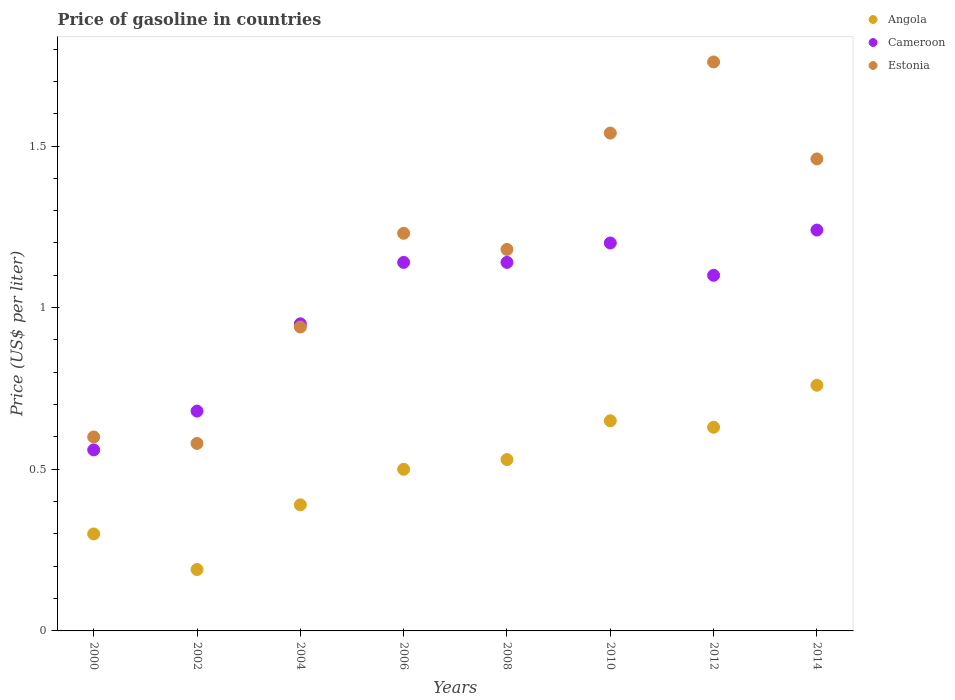How many different coloured dotlines are there?
Your response must be concise. 3. What is the price of gasoline in Estonia in 2000?
Keep it short and to the point. 0.6. Across all years, what is the maximum price of gasoline in Angola?
Your response must be concise. 0.76. Across all years, what is the minimum price of gasoline in Cameroon?
Keep it short and to the point. 0.56. In which year was the price of gasoline in Estonia maximum?
Keep it short and to the point. 2012. What is the total price of gasoline in Cameroon in the graph?
Make the answer very short. 8.01. What is the difference between the price of gasoline in Cameroon in 2004 and that in 2010?
Give a very brief answer. -0.25. What is the difference between the price of gasoline in Angola in 2010 and the price of gasoline in Estonia in 2008?
Provide a succinct answer. -0.53. What is the average price of gasoline in Angola per year?
Your answer should be very brief. 0.49. In how many years, is the price of gasoline in Estonia greater than 1.2 US$?
Your answer should be very brief. 4. What is the ratio of the price of gasoline in Cameroon in 2002 to that in 2010?
Provide a succinct answer. 0.57. What is the difference between the highest and the second highest price of gasoline in Angola?
Provide a succinct answer. 0.11. What is the difference between the highest and the lowest price of gasoline in Angola?
Ensure brevity in your answer.  0.57. In how many years, is the price of gasoline in Cameroon greater than the average price of gasoline in Cameroon taken over all years?
Make the answer very short. 5. Is the sum of the price of gasoline in Estonia in 2000 and 2014 greater than the maximum price of gasoline in Angola across all years?
Your answer should be very brief. Yes. Is it the case that in every year, the sum of the price of gasoline in Angola and price of gasoline in Cameroon  is greater than the price of gasoline in Estonia?
Offer a very short reply. No. Does the price of gasoline in Angola monotonically increase over the years?
Provide a succinct answer. No. Is the price of gasoline in Cameroon strictly greater than the price of gasoline in Angola over the years?
Provide a succinct answer. Yes. How many years are there in the graph?
Offer a terse response. 8. What is the difference between two consecutive major ticks on the Y-axis?
Make the answer very short. 0.5. Does the graph contain any zero values?
Provide a short and direct response. No. Does the graph contain grids?
Make the answer very short. No. Where does the legend appear in the graph?
Offer a terse response. Top right. What is the title of the graph?
Keep it short and to the point. Price of gasoline in countries. Does "Netherlands" appear as one of the legend labels in the graph?
Offer a very short reply. No. What is the label or title of the X-axis?
Offer a very short reply. Years. What is the label or title of the Y-axis?
Make the answer very short. Price (US$ per liter). What is the Price (US$ per liter) in Cameroon in 2000?
Your response must be concise. 0.56. What is the Price (US$ per liter) in Angola in 2002?
Give a very brief answer. 0.19. What is the Price (US$ per liter) of Cameroon in 2002?
Offer a terse response. 0.68. What is the Price (US$ per liter) in Estonia in 2002?
Your response must be concise. 0.58. What is the Price (US$ per liter) in Angola in 2004?
Your answer should be very brief. 0.39. What is the Price (US$ per liter) in Angola in 2006?
Provide a succinct answer. 0.5. What is the Price (US$ per liter) in Cameroon in 2006?
Your response must be concise. 1.14. What is the Price (US$ per liter) of Estonia in 2006?
Your answer should be very brief. 1.23. What is the Price (US$ per liter) of Angola in 2008?
Your response must be concise. 0.53. What is the Price (US$ per liter) in Cameroon in 2008?
Your response must be concise. 1.14. What is the Price (US$ per liter) in Estonia in 2008?
Provide a short and direct response. 1.18. What is the Price (US$ per liter) in Angola in 2010?
Ensure brevity in your answer.  0.65. What is the Price (US$ per liter) in Cameroon in 2010?
Keep it short and to the point. 1.2. What is the Price (US$ per liter) of Estonia in 2010?
Provide a succinct answer. 1.54. What is the Price (US$ per liter) of Angola in 2012?
Offer a very short reply. 0.63. What is the Price (US$ per liter) of Estonia in 2012?
Your response must be concise. 1.76. What is the Price (US$ per liter) of Angola in 2014?
Provide a succinct answer. 0.76. What is the Price (US$ per liter) in Cameroon in 2014?
Ensure brevity in your answer.  1.24. What is the Price (US$ per liter) of Estonia in 2014?
Provide a succinct answer. 1.46. Across all years, what is the maximum Price (US$ per liter) of Angola?
Give a very brief answer. 0.76. Across all years, what is the maximum Price (US$ per liter) in Cameroon?
Your answer should be very brief. 1.24. Across all years, what is the maximum Price (US$ per liter) in Estonia?
Offer a terse response. 1.76. Across all years, what is the minimum Price (US$ per liter) in Angola?
Keep it short and to the point. 0.19. Across all years, what is the minimum Price (US$ per liter) of Cameroon?
Provide a short and direct response. 0.56. Across all years, what is the minimum Price (US$ per liter) of Estonia?
Your response must be concise. 0.58. What is the total Price (US$ per liter) of Angola in the graph?
Offer a terse response. 3.95. What is the total Price (US$ per liter) of Cameroon in the graph?
Make the answer very short. 8.01. What is the total Price (US$ per liter) of Estonia in the graph?
Provide a succinct answer. 9.29. What is the difference between the Price (US$ per liter) in Angola in 2000 and that in 2002?
Offer a terse response. 0.11. What is the difference between the Price (US$ per liter) in Cameroon in 2000 and that in 2002?
Give a very brief answer. -0.12. What is the difference between the Price (US$ per liter) in Estonia in 2000 and that in 2002?
Your answer should be compact. 0.02. What is the difference between the Price (US$ per liter) of Angola in 2000 and that in 2004?
Give a very brief answer. -0.09. What is the difference between the Price (US$ per liter) in Cameroon in 2000 and that in 2004?
Offer a terse response. -0.39. What is the difference between the Price (US$ per liter) in Estonia in 2000 and that in 2004?
Ensure brevity in your answer.  -0.34. What is the difference between the Price (US$ per liter) in Angola in 2000 and that in 2006?
Keep it short and to the point. -0.2. What is the difference between the Price (US$ per liter) in Cameroon in 2000 and that in 2006?
Offer a terse response. -0.58. What is the difference between the Price (US$ per liter) in Estonia in 2000 and that in 2006?
Offer a terse response. -0.63. What is the difference between the Price (US$ per liter) of Angola in 2000 and that in 2008?
Ensure brevity in your answer.  -0.23. What is the difference between the Price (US$ per liter) of Cameroon in 2000 and that in 2008?
Ensure brevity in your answer.  -0.58. What is the difference between the Price (US$ per liter) in Estonia in 2000 and that in 2008?
Offer a terse response. -0.58. What is the difference between the Price (US$ per liter) in Angola in 2000 and that in 2010?
Keep it short and to the point. -0.35. What is the difference between the Price (US$ per liter) in Cameroon in 2000 and that in 2010?
Give a very brief answer. -0.64. What is the difference between the Price (US$ per liter) of Estonia in 2000 and that in 2010?
Give a very brief answer. -0.94. What is the difference between the Price (US$ per liter) of Angola in 2000 and that in 2012?
Your answer should be compact. -0.33. What is the difference between the Price (US$ per liter) of Cameroon in 2000 and that in 2012?
Offer a terse response. -0.54. What is the difference between the Price (US$ per liter) of Estonia in 2000 and that in 2012?
Make the answer very short. -1.16. What is the difference between the Price (US$ per liter) of Angola in 2000 and that in 2014?
Your response must be concise. -0.46. What is the difference between the Price (US$ per liter) of Cameroon in 2000 and that in 2014?
Your response must be concise. -0.68. What is the difference between the Price (US$ per liter) in Estonia in 2000 and that in 2014?
Your response must be concise. -0.86. What is the difference between the Price (US$ per liter) of Angola in 2002 and that in 2004?
Offer a terse response. -0.2. What is the difference between the Price (US$ per liter) of Cameroon in 2002 and that in 2004?
Provide a succinct answer. -0.27. What is the difference between the Price (US$ per liter) in Estonia in 2002 and that in 2004?
Keep it short and to the point. -0.36. What is the difference between the Price (US$ per liter) of Angola in 2002 and that in 2006?
Your answer should be very brief. -0.31. What is the difference between the Price (US$ per liter) of Cameroon in 2002 and that in 2006?
Your answer should be very brief. -0.46. What is the difference between the Price (US$ per liter) in Estonia in 2002 and that in 2006?
Keep it short and to the point. -0.65. What is the difference between the Price (US$ per liter) of Angola in 2002 and that in 2008?
Your answer should be very brief. -0.34. What is the difference between the Price (US$ per liter) in Cameroon in 2002 and that in 2008?
Ensure brevity in your answer.  -0.46. What is the difference between the Price (US$ per liter) in Estonia in 2002 and that in 2008?
Offer a terse response. -0.6. What is the difference between the Price (US$ per liter) in Angola in 2002 and that in 2010?
Make the answer very short. -0.46. What is the difference between the Price (US$ per liter) in Cameroon in 2002 and that in 2010?
Make the answer very short. -0.52. What is the difference between the Price (US$ per liter) in Estonia in 2002 and that in 2010?
Your answer should be very brief. -0.96. What is the difference between the Price (US$ per liter) of Angola in 2002 and that in 2012?
Provide a short and direct response. -0.44. What is the difference between the Price (US$ per liter) in Cameroon in 2002 and that in 2012?
Your response must be concise. -0.42. What is the difference between the Price (US$ per liter) in Estonia in 2002 and that in 2012?
Your answer should be compact. -1.18. What is the difference between the Price (US$ per liter) in Angola in 2002 and that in 2014?
Offer a very short reply. -0.57. What is the difference between the Price (US$ per liter) in Cameroon in 2002 and that in 2014?
Ensure brevity in your answer.  -0.56. What is the difference between the Price (US$ per liter) of Estonia in 2002 and that in 2014?
Make the answer very short. -0.88. What is the difference between the Price (US$ per liter) of Angola in 2004 and that in 2006?
Make the answer very short. -0.11. What is the difference between the Price (US$ per liter) of Cameroon in 2004 and that in 2006?
Offer a very short reply. -0.19. What is the difference between the Price (US$ per liter) of Estonia in 2004 and that in 2006?
Offer a very short reply. -0.29. What is the difference between the Price (US$ per liter) of Angola in 2004 and that in 2008?
Make the answer very short. -0.14. What is the difference between the Price (US$ per liter) of Cameroon in 2004 and that in 2008?
Provide a short and direct response. -0.19. What is the difference between the Price (US$ per liter) in Estonia in 2004 and that in 2008?
Keep it short and to the point. -0.24. What is the difference between the Price (US$ per liter) of Angola in 2004 and that in 2010?
Provide a succinct answer. -0.26. What is the difference between the Price (US$ per liter) of Cameroon in 2004 and that in 2010?
Offer a very short reply. -0.25. What is the difference between the Price (US$ per liter) in Angola in 2004 and that in 2012?
Provide a succinct answer. -0.24. What is the difference between the Price (US$ per liter) of Cameroon in 2004 and that in 2012?
Keep it short and to the point. -0.15. What is the difference between the Price (US$ per liter) of Estonia in 2004 and that in 2012?
Give a very brief answer. -0.82. What is the difference between the Price (US$ per liter) in Angola in 2004 and that in 2014?
Give a very brief answer. -0.37. What is the difference between the Price (US$ per liter) of Cameroon in 2004 and that in 2014?
Provide a succinct answer. -0.29. What is the difference between the Price (US$ per liter) of Estonia in 2004 and that in 2014?
Your response must be concise. -0.52. What is the difference between the Price (US$ per liter) of Angola in 2006 and that in 2008?
Offer a terse response. -0.03. What is the difference between the Price (US$ per liter) of Cameroon in 2006 and that in 2008?
Offer a terse response. 0. What is the difference between the Price (US$ per liter) of Angola in 2006 and that in 2010?
Provide a succinct answer. -0.15. What is the difference between the Price (US$ per liter) of Cameroon in 2006 and that in 2010?
Offer a very short reply. -0.06. What is the difference between the Price (US$ per liter) in Estonia in 2006 and that in 2010?
Offer a very short reply. -0.31. What is the difference between the Price (US$ per liter) of Angola in 2006 and that in 2012?
Offer a terse response. -0.13. What is the difference between the Price (US$ per liter) of Cameroon in 2006 and that in 2012?
Give a very brief answer. 0.04. What is the difference between the Price (US$ per liter) of Estonia in 2006 and that in 2012?
Provide a short and direct response. -0.53. What is the difference between the Price (US$ per liter) of Angola in 2006 and that in 2014?
Ensure brevity in your answer.  -0.26. What is the difference between the Price (US$ per liter) in Cameroon in 2006 and that in 2014?
Ensure brevity in your answer.  -0.1. What is the difference between the Price (US$ per liter) in Estonia in 2006 and that in 2014?
Offer a terse response. -0.23. What is the difference between the Price (US$ per liter) in Angola in 2008 and that in 2010?
Offer a very short reply. -0.12. What is the difference between the Price (US$ per liter) of Cameroon in 2008 and that in 2010?
Offer a very short reply. -0.06. What is the difference between the Price (US$ per liter) in Estonia in 2008 and that in 2010?
Ensure brevity in your answer.  -0.36. What is the difference between the Price (US$ per liter) of Cameroon in 2008 and that in 2012?
Your response must be concise. 0.04. What is the difference between the Price (US$ per liter) of Estonia in 2008 and that in 2012?
Your answer should be very brief. -0.58. What is the difference between the Price (US$ per liter) in Angola in 2008 and that in 2014?
Ensure brevity in your answer.  -0.23. What is the difference between the Price (US$ per liter) in Cameroon in 2008 and that in 2014?
Your answer should be very brief. -0.1. What is the difference between the Price (US$ per liter) of Estonia in 2008 and that in 2014?
Offer a terse response. -0.28. What is the difference between the Price (US$ per liter) of Angola in 2010 and that in 2012?
Give a very brief answer. 0.02. What is the difference between the Price (US$ per liter) in Estonia in 2010 and that in 2012?
Your response must be concise. -0.22. What is the difference between the Price (US$ per liter) of Angola in 2010 and that in 2014?
Provide a short and direct response. -0.11. What is the difference between the Price (US$ per liter) of Cameroon in 2010 and that in 2014?
Offer a terse response. -0.04. What is the difference between the Price (US$ per liter) in Angola in 2012 and that in 2014?
Give a very brief answer. -0.13. What is the difference between the Price (US$ per liter) in Cameroon in 2012 and that in 2014?
Your response must be concise. -0.14. What is the difference between the Price (US$ per liter) in Angola in 2000 and the Price (US$ per liter) in Cameroon in 2002?
Give a very brief answer. -0.38. What is the difference between the Price (US$ per liter) in Angola in 2000 and the Price (US$ per liter) in Estonia in 2002?
Offer a very short reply. -0.28. What is the difference between the Price (US$ per liter) of Cameroon in 2000 and the Price (US$ per liter) of Estonia in 2002?
Give a very brief answer. -0.02. What is the difference between the Price (US$ per liter) of Angola in 2000 and the Price (US$ per liter) of Cameroon in 2004?
Provide a short and direct response. -0.65. What is the difference between the Price (US$ per liter) in Angola in 2000 and the Price (US$ per liter) in Estonia in 2004?
Keep it short and to the point. -0.64. What is the difference between the Price (US$ per liter) of Cameroon in 2000 and the Price (US$ per liter) of Estonia in 2004?
Offer a very short reply. -0.38. What is the difference between the Price (US$ per liter) of Angola in 2000 and the Price (US$ per liter) of Cameroon in 2006?
Make the answer very short. -0.84. What is the difference between the Price (US$ per liter) in Angola in 2000 and the Price (US$ per liter) in Estonia in 2006?
Offer a very short reply. -0.93. What is the difference between the Price (US$ per liter) of Cameroon in 2000 and the Price (US$ per liter) of Estonia in 2006?
Your answer should be compact. -0.67. What is the difference between the Price (US$ per liter) in Angola in 2000 and the Price (US$ per liter) in Cameroon in 2008?
Offer a terse response. -0.84. What is the difference between the Price (US$ per liter) of Angola in 2000 and the Price (US$ per liter) of Estonia in 2008?
Make the answer very short. -0.88. What is the difference between the Price (US$ per liter) in Cameroon in 2000 and the Price (US$ per liter) in Estonia in 2008?
Offer a very short reply. -0.62. What is the difference between the Price (US$ per liter) in Angola in 2000 and the Price (US$ per liter) in Estonia in 2010?
Offer a terse response. -1.24. What is the difference between the Price (US$ per liter) of Cameroon in 2000 and the Price (US$ per liter) of Estonia in 2010?
Your answer should be very brief. -0.98. What is the difference between the Price (US$ per liter) in Angola in 2000 and the Price (US$ per liter) in Cameroon in 2012?
Give a very brief answer. -0.8. What is the difference between the Price (US$ per liter) in Angola in 2000 and the Price (US$ per liter) in Estonia in 2012?
Keep it short and to the point. -1.46. What is the difference between the Price (US$ per liter) in Cameroon in 2000 and the Price (US$ per liter) in Estonia in 2012?
Make the answer very short. -1.2. What is the difference between the Price (US$ per liter) of Angola in 2000 and the Price (US$ per liter) of Cameroon in 2014?
Ensure brevity in your answer.  -0.94. What is the difference between the Price (US$ per liter) of Angola in 2000 and the Price (US$ per liter) of Estonia in 2014?
Make the answer very short. -1.16. What is the difference between the Price (US$ per liter) in Angola in 2002 and the Price (US$ per liter) in Cameroon in 2004?
Make the answer very short. -0.76. What is the difference between the Price (US$ per liter) in Angola in 2002 and the Price (US$ per liter) in Estonia in 2004?
Keep it short and to the point. -0.75. What is the difference between the Price (US$ per liter) in Cameroon in 2002 and the Price (US$ per liter) in Estonia in 2004?
Your answer should be compact. -0.26. What is the difference between the Price (US$ per liter) of Angola in 2002 and the Price (US$ per liter) of Cameroon in 2006?
Provide a short and direct response. -0.95. What is the difference between the Price (US$ per liter) of Angola in 2002 and the Price (US$ per liter) of Estonia in 2006?
Provide a short and direct response. -1.04. What is the difference between the Price (US$ per liter) in Cameroon in 2002 and the Price (US$ per liter) in Estonia in 2006?
Offer a very short reply. -0.55. What is the difference between the Price (US$ per liter) in Angola in 2002 and the Price (US$ per liter) in Cameroon in 2008?
Your response must be concise. -0.95. What is the difference between the Price (US$ per liter) of Angola in 2002 and the Price (US$ per liter) of Estonia in 2008?
Your answer should be compact. -0.99. What is the difference between the Price (US$ per liter) of Cameroon in 2002 and the Price (US$ per liter) of Estonia in 2008?
Offer a terse response. -0.5. What is the difference between the Price (US$ per liter) in Angola in 2002 and the Price (US$ per liter) in Cameroon in 2010?
Offer a terse response. -1.01. What is the difference between the Price (US$ per liter) in Angola in 2002 and the Price (US$ per liter) in Estonia in 2010?
Offer a terse response. -1.35. What is the difference between the Price (US$ per liter) in Cameroon in 2002 and the Price (US$ per liter) in Estonia in 2010?
Your answer should be compact. -0.86. What is the difference between the Price (US$ per liter) in Angola in 2002 and the Price (US$ per liter) in Cameroon in 2012?
Keep it short and to the point. -0.91. What is the difference between the Price (US$ per liter) in Angola in 2002 and the Price (US$ per liter) in Estonia in 2012?
Your response must be concise. -1.57. What is the difference between the Price (US$ per liter) of Cameroon in 2002 and the Price (US$ per liter) of Estonia in 2012?
Give a very brief answer. -1.08. What is the difference between the Price (US$ per liter) of Angola in 2002 and the Price (US$ per liter) of Cameroon in 2014?
Offer a very short reply. -1.05. What is the difference between the Price (US$ per liter) in Angola in 2002 and the Price (US$ per liter) in Estonia in 2014?
Provide a succinct answer. -1.27. What is the difference between the Price (US$ per liter) in Cameroon in 2002 and the Price (US$ per liter) in Estonia in 2014?
Ensure brevity in your answer.  -0.78. What is the difference between the Price (US$ per liter) in Angola in 2004 and the Price (US$ per liter) in Cameroon in 2006?
Your response must be concise. -0.75. What is the difference between the Price (US$ per liter) of Angola in 2004 and the Price (US$ per liter) of Estonia in 2006?
Give a very brief answer. -0.84. What is the difference between the Price (US$ per liter) in Cameroon in 2004 and the Price (US$ per liter) in Estonia in 2006?
Make the answer very short. -0.28. What is the difference between the Price (US$ per liter) in Angola in 2004 and the Price (US$ per liter) in Cameroon in 2008?
Offer a very short reply. -0.75. What is the difference between the Price (US$ per liter) of Angola in 2004 and the Price (US$ per liter) of Estonia in 2008?
Provide a short and direct response. -0.79. What is the difference between the Price (US$ per liter) in Cameroon in 2004 and the Price (US$ per liter) in Estonia in 2008?
Ensure brevity in your answer.  -0.23. What is the difference between the Price (US$ per liter) in Angola in 2004 and the Price (US$ per liter) in Cameroon in 2010?
Ensure brevity in your answer.  -0.81. What is the difference between the Price (US$ per liter) in Angola in 2004 and the Price (US$ per liter) in Estonia in 2010?
Give a very brief answer. -1.15. What is the difference between the Price (US$ per liter) in Cameroon in 2004 and the Price (US$ per liter) in Estonia in 2010?
Your answer should be compact. -0.59. What is the difference between the Price (US$ per liter) of Angola in 2004 and the Price (US$ per liter) of Cameroon in 2012?
Your response must be concise. -0.71. What is the difference between the Price (US$ per liter) in Angola in 2004 and the Price (US$ per liter) in Estonia in 2012?
Offer a very short reply. -1.37. What is the difference between the Price (US$ per liter) of Cameroon in 2004 and the Price (US$ per liter) of Estonia in 2012?
Your response must be concise. -0.81. What is the difference between the Price (US$ per liter) in Angola in 2004 and the Price (US$ per liter) in Cameroon in 2014?
Your answer should be very brief. -0.85. What is the difference between the Price (US$ per liter) of Angola in 2004 and the Price (US$ per liter) of Estonia in 2014?
Your answer should be very brief. -1.07. What is the difference between the Price (US$ per liter) in Cameroon in 2004 and the Price (US$ per liter) in Estonia in 2014?
Your response must be concise. -0.51. What is the difference between the Price (US$ per liter) of Angola in 2006 and the Price (US$ per liter) of Cameroon in 2008?
Offer a terse response. -0.64. What is the difference between the Price (US$ per liter) of Angola in 2006 and the Price (US$ per liter) of Estonia in 2008?
Provide a short and direct response. -0.68. What is the difference between the Price (US$ per liter) of Cameroon in 2006 and the Price (US$ per liter) of Estonia in 2008?
Your answer should be very brief. -0.04. What is the difference between the Price (US$ per liter) of Angola in 2006 and the Price (US$ per liter) of Estonia in 2010?
Keep it short and to the point. -1.04. What is the difference between the Price (US$ per liter) of Angola in 2006 and the Price (US$ per liter) of Estonia in 2012?
Offer a very short reply. -1.26. What is the difference between the Price (US$ per liter) in Cameroon in 2006 and the Price (US$ per liter) in Estonia in 2012?
Provide a short and direct response. -0.62. What is the difference between the Price (US$ per liter) of Angola in 2006 and the Price (US$ per liter) of Cameroon in 2014?
Your answer should be very brief. -0.74. What is the difference between the Price (US$ per liter) of Angola in 2006 and the Price (US$ per liter) of Estonia in 2014?
Provide a short and direct response. -0.96. What is the difference between the Price (US$ per liter) in Cameroon in 2006 and the Price (US$ per liter) in Estonia in 2014?
Make the answer very short. -0.32. What is the difference between the Price (US$ per liter) in Angola in 2008 and the Price (US$ per liter) in Cameroon in 2010?
Your answer should be very brief. -0.67. What is the difference between the Price (US$ per liter) in Angola in 2008 and the Price (US$ per liter) in Estonia in 2010?
Ensure brevity in your answer.  -1.01. What is the difference between the Price (US$ per liter) of Angola in 2008 and the Price (US$ per liter) of Cameroon in 2012?
Your answer should be compact. -0.57. What is the difference between the Price (US$ per liter) of Angola in 2008 and the Price (US$ per liter) of Estonia in 2012?
Offer a very short reply. -1.23. What is the difference between the Price (US$ per liter) of Cameroon in 2008 and the Price (US$ per liter) of Estonia in 2012?
Provide a succinct answer. -0.62. What is the difference between the Price (US$ per liter) of Angola in 2008 and the Price (US$ per liter) of Cameroon in 2014?
Provide a succinct answer. -0.71. What is the difference between the Price (US$ per liter) of Angola in 2008 and the Price (US$ per liter) of Estonia in 2014?
Give a very brief answer. -0.93. What is the difference between the Price (US$ per liter) in Cameroon in 2008 and the Price (US$ per liter) in Estonia in 2014?
Make the answer very short. -0.32. What is the difference between the Price (US$ per liter) of Angola in 2010 and the Price (US$ per liter) of Cameroon in 2012?
Keep it short and to the point. -0.45. What is the difference between the Price (US$ per liter) in Angola in 2010 and the Price (US$ per liter) in Estonia in 2012?
Provide a succinct answer. -1.11. What is the difference between the Price (US$ per liter) of Cameroon in 2010 and the Price (US$ per liter) of Estonia in 2012?
Give a very brief answer. -0.56. What is the difference between the Price (US$ per liter) of Angola in 2010 and the Price (US$ per liter) of Cameroon in 2014?
Your answer should be compact. -0.59. What is the difference between the Price (US$ per liter) in Angola in 2010 and the Price (US$ per liter) in Estonia in 2014?
Your response must be concise. -0.81. What is the difference between the Price (US$ per liter) in Cameroon in 2010 and the Price (US$ per liter) in Estonia in 2014?
Your response must be concise. -0.26. What is the difference between the Price (US$ per liter) in Angola in 2012 and the Price (US$ per liter) in Cameroon in 2014?
Your response must be concise. -0.61. What is the difference between the Price (US$ per liter) in Angola in 2012 and the Price (US$ per liter) in Estonia in 2014?
Your response must be concise. -0.83. What is the difference between the Price (US$ per liter) in Cameroon in 2012 and the Price (US$ per liter) in Estonia in 2014?
Provide a succinct answer. -0.36. What is the average Price (US$ per liter) of Angola per year?
Offer a very short reply. 0.49. What is the average Price (US$ per liter) in Estonia per year?
Provide a short and direct response. 1.16. In the year 2000, what is the difference between the Price (US$ per liter) of Angola and Price (US$ per liter) of Cameroon?
Ensure brevity in your answer.  -0.26. In the year 2000, what is the difference between the Price (US$ per liter) in Cameroon and Price (US$ per liter) in Estonia?
Make the answer very short. -0.04. In the year 2002, what is the difference between the Price (US$ per liter) in Angola and Price (US$ per liter) in Cameroon?
Offer a terse response. -0.49. In the year 2002, what is the difference between the Price (US$ per liter) of Angola and Price (US$ per liter) of Estonia?
Keep it short and to the point. -0.39. In the year 2002, what is the difference between the Price (US$ per liter) in Cameroon and Price (US$ per liter) in Estonia?
Provide a short and direct response. 0.1. In the year 2004, what is the difference between the Price (US$ per liter) in Angola and Price (US$ per liter) in Cameroon?
Your answer should be compact. -0.56. In the year 2004, what is the difference between the Price (US$ per liter) in Angola and Price (US$ per liter) in Estonia?
Provide a succinct answer. -0.55. In the year 2006, what is the difference between the Price (US$ per liter) in Angola and Price (US$ per liter) in Cameroon?
Offer a terse response. -0.64. In the year 2006, what is the difference between the Price (US$ per liter) in Angola and Price (US$ per liter) in Estonia?
Give a very brief answer. -0.73. In the year 2006, what is the difference between the Price (US$ per liter) of Cameroon and Price (US$ per liter) of Estonia?
Keep it short and to the point. -0.09. In the year 2008, what is the difference between the Price (US$ per liter) of Angola and Price (US$ per liter) of Cameroon?
Your answer should be very brief. -0.61. In the year 2008, what is the difference between the Price (US$ per liter) in Angola and Price (US$ per liter) in Estonia?
Your response must be concise. -0.65. In the year 2008, what is the difference between the Price (US$ per liter) in Cameroon and Price (US$ per liter) in Estonia?
Make the answer very short. -0.04. In the year 2010, what is the difference between the Price (US$ per liter) in Angola and Price (US$ per liter) in Cameroon?
Your answer should be very brief. -0.55. In the year 2010, what is the difference between the Price (US$ per liter) of Angola and Price (US$ per liter) of Estonia?
Offer a very short reply. -0.89. In the year 2010, what is the difference between the Price (US$ per liter) of Cameroon and Price (US$ per liter) of Estonia?
Offer a terse response. -0.34. In the year 2012, what is the difference between the Price (US$ per liter) of Angola and Price (US$ per liter) of Cameroon?
Offer a terse response. -0.47. In the year 2012, what is the difference between the Price (US$ per liter) in Angola and Price (US$ per liter) in Estonia?
Provide a short and direct response. -1.13. In the year 2012, what is the difference between the Price (US$ per liter) in Cameroon and Price (US$ per liter) in Estonia?
Give a very brief answer. -0.66. In the year 2014, what is the difference between the Price (US$ per liter) of Angola and Price (US$ per liter) of Cameroon?
Ensure brevity in your answer.  -0.48. In the year 2014, what is the difference between the Price (US$ per liter) in Cameroon and Price (US$ per liter) in Estonia?
Provide a short and direct response. -0.22. What is the ratio of the Price (US$ per liter) of Angola in 2000 to that in 2002?
Offer a very short reply. 1.58. What is the ratio of the Price (US$ per liter) in Cameroon in 2000 to that in 2002?
Provide a succinct answer. 0.82. What is the ratio of the Price (US$ per liter) of Estonia in 2000 to that in 2002?
Your answer should be very brief. 1.03. What is the ratio of the Price (US$ per liter) of Angola in 2000 to that in 2004?
Ensure brevity in your answer.  0.77. What is the ratio of the Price (US$ per liter) in Cameroon in 2000 to that in 2004?
Give a very brief answer. 0.59. What is the ratio of the Price (US$ per liter) of Estonia in 2000 to that in 2004?
Give a very brief answer. 0.64. What is the ratio of the Price (US$ per liter) of Angola in 2000 to that in 2006?
Provide a short and direct response. 0.6. What is the ratio of the Price (US$ per liter) of Cameroon in 2000 to that in 2006?
Ensure brevity in your answer.  0.49. What is the ratio of the Price (US$ per liter) of Estonia in 2000 to that in 2006?
Your answer should be compact. 0.49. What is the ratio of the Price (US$ per liter) of Angola in 2000 to that in 2008?
Your response must be concise. 0.57. What is the ratio of the Price (US$ per liter) of Cameroon in 2000 to that in 2008?
Ensure brevity in your answer.  0.49. What is the ratio of the Price (US$ per liter) of Estonia in 2000 to that in 2008?
Keep it short and to the point. 0.51. What is the ratio of the Price (US$ per liter) of Angola in 2000 to that in 2010?
Keep it short and to the point. 0.46. What is the ratio of the Price (US$ per liter) in Cameroon in 2000 to that in 2010?
Provide a short and direct response. 0.47. What is the ratio of the Price (US$ per liter) in Estonia in 2000 to that in 2010?
Ensure brevity in your answer.  0.39. What is the ratio of the Price (US$ per liter) of Angola in 2000 to that in 2012?
Your response must be concise. 0.48. What is the ratio of the Price (US$ per liter) of Cameroon in 2000 to that in 2012?
Provide a short and direct response. 0.51. What is the ratio of the Price (US$ per liter) in Estonia in 2000 to that in 2012?
Give a very brief answer. 0.34. What is the ratio of the Price (US$ per liter) of Angola in 2000 to that in 2014?
Your answer should be very brief. 0.39. What is the ratio of the Price (US$ per liter) of Cameroon in 2000 to that in 2014?
Give a very brief answer. 0.45. What is the ratio of the Price (US$ per liter) of Estonia in 2000 to that in 2014?
Give a very brief answer. 0.41. What is the ratio of the Price (US$ per liter) of Angola in 2002 to that in 2004?
Offer a terse response. 0.49. What is the ratio of the Price (US$ per liter) of Cameroon in 2002 to that in 2004?
Ensure brevity in your answer.  0.72. What is the ratio of the Price (US$ per liter) of Estonia in 2002 to that in 2004?
Your answer should be very brief. 0.62. What is the ratio of the Price (US$ per liter) in Angola in 2002 to that in 2006?
Make the answer very short. 0.38. What is the ratio of the Price (US$ per liter) of Cameroon in 2002 to that in 2006?
Your answer should be very brief. 0.6. What is the ratio of the Price (US$ per liter) of Estonia in 2002 to that in 2006?
Make the answer very short. 0.47. What is the ratio of the Price (US$ per liter) in Angola in 2002 to that in 2008?
Your response must be concise. 0.36. What is the ratio of the Price (US$ per liter) in Cameroon in 2002 to that in 2008?
Provide a short and direct response. 0.6. What is the ratio of the Price (US$ per liter) in Estonia in 2002 to that in 2008?
Provide a succinct answer. 0.49. What is the ratio of the Price (US$ per liter) in Angola in 2002 to that in 2010?
Your answer should be compact. 0.29. What is the ratio of the Price (US$ per liter) in Cameroon in 2002 to that in 2010?
Offer a very short reply. 0.57. What is the ratio of the Price (US$ per liter) of Estonia in 2002 to that in 2010?
Make the answer very short. 0.38. What is the ratio of the Price (US$ per liter) in Angola in 2002 to that in 2012?
Your answer should be very brief. 0.3. What is the ratio of the Price (US$ per liter) of Cameroon in 2002 to that in 2012?
Provide a short and direct response. 0.62. What is the ratio of the Price (US$ per liter) in Estonia in 2002 to that in 2012?
Keep it short and to the point. 0.33. What is the ratio of the Price (US$ per liter) in Cameroon in 2002 to that in 2014?
Offer a terse response. 0.55. What is the ratio of the Price (US$ per liter) of Estonia in 2002 to that in 2014?
Give a very brief answer. 0.4. What is the ratio of the Price (US$ per liter) of Angola in 2004 to that in 2006?
Ensure brevity in your answer.  0.78. What is the ratio of the Price (US$ per liter) in Cameroon in 2004 to that in 2006?
Make the answer very short. 0.83. What is the ratio of the Price (US$ per liter) in Estonia in 2004 to that in 2006?
Your answer should be very brief. 0.76. What is the ratio of the Price (US$ per liter) of Angola in 2004 to that in 2008?
Ensure brevity in your answer.  0.74. What is the ratio of the Price (US$ per liter) of Cameroon in 2004 to that in 2008?
Offer a very short reply. 0.83. What is the ratio of the Price (US$ per liter) of Estonia in 2004 to that in 2008?
Your response must be concise. 0.8. What is the ratio of the Price (US$ per liter) of Angola in 2004 to that in 2010?
Provide a succinct answer. 0.6. What is the ratio of the Price (US$ per liter) in Cameroon in 2004 to that in 2010?
Provide a short and direct response. 0.79. What is the ratio of the Price (US$ per liter) of Estonia in 2004 to that in 2010?
Keep it short and to the point. 0.61. What is the ratio of the Price (US$ per liter) in Angola in 2004 to that in 2012?
Your response must be concise. 0.62. What is the ratio of the Price (US$ per liter) of Cameroon in 2004 to that in 2012?
Provide a short and direct response. 0.86. What is the ratio of the Price (US$ per liter) of Estonia in 2004 to that in 2012?
Your answer should be very brief. 0.53. What is the ratio of the Price (US$ per liter) in Angola in 2004 to that in 2014?
Offer a terse response. 0.51. What is the ratio of the Price (US$ per liter) of Cameroon in 2004 to that in 2014?
Give a very brief answer. 0.77. What is the ratio of the Price (US$ per liter) in Estonia in 2004 to that in 2014?
Give a very brief answer. 0.64. What is the ratio of the Price (US$ per liter) of Angola in 2006 to that in 2008?
Offer a terse response. 0.94. What is the ratio of the Price (US$ per liter) in Cameroon in 2006 to that in 2008?
Ensure brevity in your answer.  1. What is the ratio of the Price (US$ per liter) in Estonia in 2006 to that in 2008?
Keep it short and to the point. 1.04. What is the ratio of the Price (US$ per liter) of Angola in 2006 to that in 2010?
Keep it short and to the point. 0.77. What is the ratio of the Price (US$ per liter) in Cameroon in 2006 to that in 2010?
Keep it short and to the point. 0.95. What is the ratio of the Price (US$ per liter) of Estonia in 2006 to that in 2010?
Your response must be concise. 0.8. What is the ratio of the Price (US$ per liter) in Angola in 2006 to that in 2012?
Your answer should be compact. 0.79. What is the ratio of the Price (US$ per liter) of Cameroon in 2006 to that in 2012?
Keep it short and to the point. 1.04. What is the ratio of the Price (US$ per liter) of Estonia in 2006 to that in 2012?
Provide a succinct answer. 0.7. What is the ratio of the Price (US$ per liter) of Angola in 2006 to that in 2014?
Offer a very short reply. 0.66. What is the ratio of the Price (US$ per liter) in Cameroon in 2006 to that in 2014?
Your response must be concise. 0.92. What is the ratio of the Price (US$ per liter) of Estonia in 2006 to that in 2014?
Provide a succinct answer. 0.84. What is the ratio of the Price (US$ per liter) of Angola in 2008 to that in 2010?
Offer a terse response. 0.82. What is the ratio of the Price (US$ per liter) of Estonia in 2008 to that in 2010?
Provide a succinct answer. 0.77. What is the ratio of the Price (US$ per liter) of Angola in 2008 to that in 2012?
Your response must be concise. 0.84. What is the ratio of the Price (US$ per liter) of Cameroon in 2008 to that in 2012?
Your response must be concise. 1.04. What is the ratio of the Price (US$ per liter) of Estonia in 2008 to that in 2012?
Provide a succinct answer. 0.67. What is the ratio of the Price (US$ per liter) of Angola in 2008 to that in 2014?
Your answer should be compact. 0.7. What is the ratio of the Price (US$ per liter) of Cameroon in 2008 to that in 2014?
Provide a short and direct response. 0.92. What is the ratio of the Price (US$ per liter) in Estonia in 2008 to that in 2014?
Your answer should be very brief. 0.81. What is the ratio of the Price (US$ per liter) in Angola in 2010 to that in 2012?
Make the answer very short. 1.03. What is the ratio of the Price (US$ per liter) of Angola in 2010 to that in 2014?
Provide a succinct answer. 0.86. What is the ratio of the Price (US$ per liter) of Cameroon in 2010 to that in 2014?
Give a very brief answer. 0.97. What is the ratio of the Price (US$ per liter) in Estonia in 2010 to that in 2014?
Your answer should be compact. 1.05. What is the ratio of the Price (US$ per liter) of Angola in 2012 to that in 2014?
Keep it short and to the point. 0.83. What is the ratio of the Price (US$ per liter) of Cameroon in 2012 to that in 2014?
Offer a terse response. 0.89. What is the ratio of the Price (US$ per liter) of Estonia in 2012 to that in 2014?
Offer a terse response. 1.21. What is the difference between the highest and the second highest Price (US$ per liter) in Angola?
Keep it short and to the point. 0.11. What is the difference between the highest and the second highest Price (US$ per liter) in Estonia?
Your answer should be compact. 0.22. What is the difference between the highest and the lowest Price (US$ per liter) in Angola?
Ensure brevity in your answer.  0.57. What is the difference between the highest and the lowest Price (US$ per liter) in Cameroon?
Provide a succinct answer. 0.68. What is the difference between the highest and the lowest Price (US$ per liter) in Estonia?
Your answer should be compact. 1.18. 